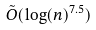<formula> <loc_0><loc_0><loc_500><loc_500>\tilde { O } ( \log ( n ) ^ { 7 . 5 } )</formula> 